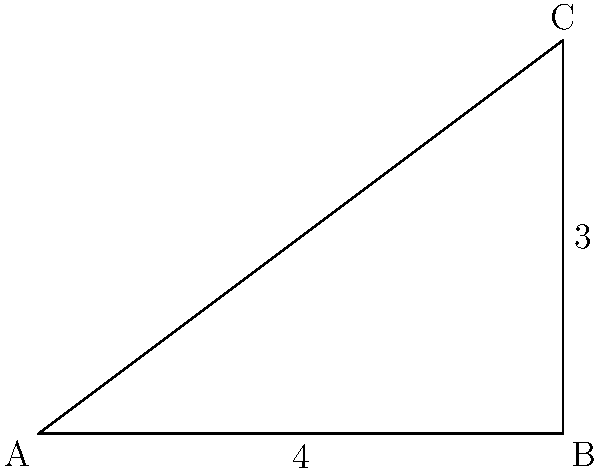In a right-angled triangle ABC, where the right angle is at B, the length of the base (AB) is 4 units and the height (BC) is 3 units. Calculate the length of the altitude drawn from point C to the hypotenuse AC. Let's approach this step-by-step:

1) First, we need to find the length of the hypotenuse AC using the Pythagorean theorem:
   $AC^2 = AB^2 + BC^2 = 4^2 + 3^2 = 16 + 9 = 25$
   $AC = \sqrt{25} = 5$ units

2) Now, let's call the altitude from C to AC as h. This altitude creates two similar right triangles.

3) We can use the property that the altitude to the hypotenuse divides the triangle into two triangles similar to the original and to each other.

4) The ratio of the altitude to either leg of the original triangle is equal to the ratio of that leg to the hypotenuse. We can use this to set up an equation:

   $\frac{h}{3} = \frac{3}{5}$

5) Cross multiply:
   $5h = 9$

6) Solve for h:
   $h = \frac{9}{5} = 1.8$ units

Therefore, the length of the altitude from C to AC is 1.8 units.
Answer: $\frac{9}{5}$ or 1.8 units 